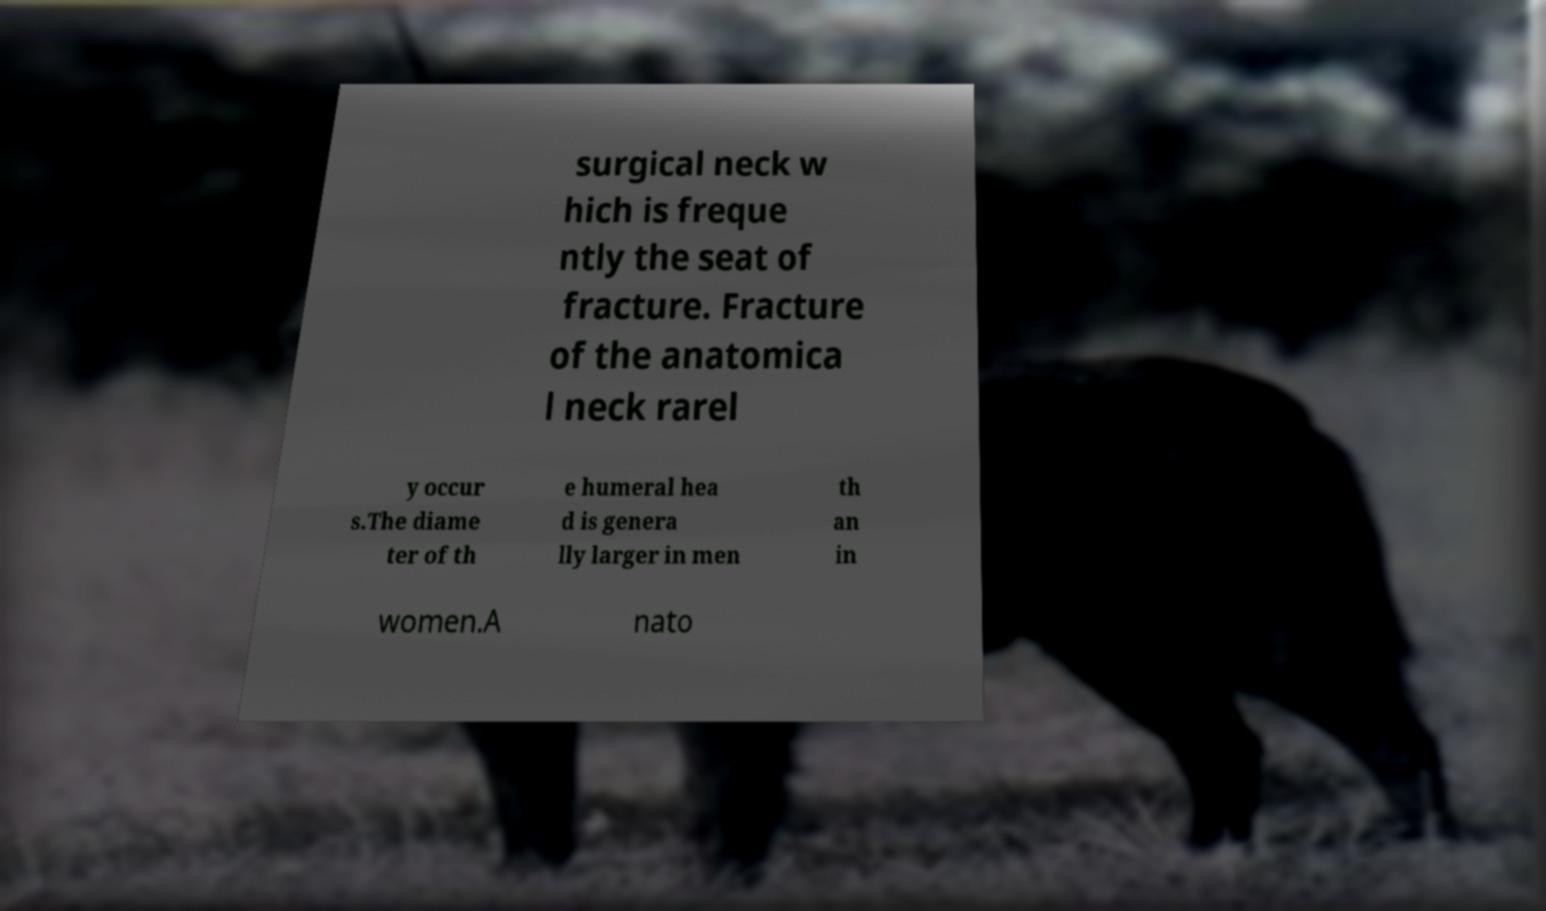For documentation purposes, I need the text within this image transcribed. Could you provide that? surgical neck w hich is freque ntly the seat of fracture. Fracture of the anatomica l neck rarel y occur s.The diame ter of th e humeral hea d is genera lly larger in men th an in women.A nato 